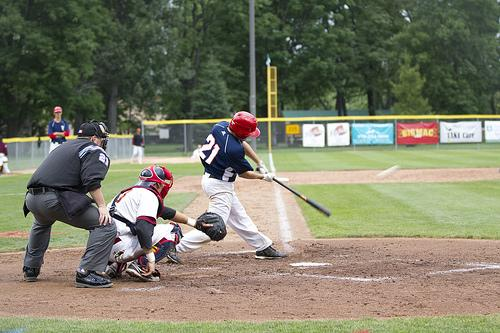Assess the image quality in terms of clarity and composition. The image quality is generally good, featuring clear details of the game, players, and surrounding elements, though it could be better composed by focusing on a few key aspects. Briefly describe any object interactions observed within the baseball field. The batter has just hit the ball, an umpire is crouching behind the catcher, and the third base coach watches from the sidelines. What is the sentiment conveyed by the image? The image conveys excitement and competition as it captures various actions of a fast-paced baseball game. List the key objects and where they are located using their top-left corner coordinates (X, Y). Umpire: (18, 115), Blue-jersey batter: (193, 116), White-jersey catcher: (98, 181), Red batting helmet: (225, 105), Metal fence: (143, 121), White home plate: (290, 259). Count the total number of unique persons in the image. There are at least 6 unique persons, including the batter, catcher, umpire, third base coach, and two individuals in the background. What activity is predominantly taking place in the image? A baseball game is taking place with various players performing different actions. Mention the colors of the teams' jerseys in the image and what roles they correspond to. The batter's team wears blue jerseys, the catcher's team wears white jerseys, and the umpire traditionally wears black. In this baseball game, which team traditionally wears white? The home team. Describe the motion of the batter. The batter has just hit the ball. What is the role of the person crouching behind the catcher? Umpire. Create a detailed image caption that captures the scene. A tense moment on a baseball field where the batter in a blue jersey hits the ball, surrounded by an umpire in black, and teammates in white; sponsors' banners line the fence. Describe the position of the man standing in the baseball field. On the sidelines. Can you see a pink elephant on the baseball field? There is no mention or indication of a pink elephant in the image, and it is not relevant to the context of a baseball game. Are there fireworks going off in the background of the image? There is no mention or indication of fireworks in the image, and it is not relevant to the context of a baseball game. What is the color of the catcher's mitt? Black. Is the umpire wearing a bright green outfit? The umpire is traditionally wearing black, not bright green. What is happening on the baseball field? People are playing a game, with a batter hitting the ball, a catcher behind him, and an umpire observing. How is the third base coach positioned? He's watching from the sidelines. Is the batter's helmet red or blue? Answer:  Which object helps decide if a baseball stays in the field of play? Yellow pole in the baseball field. What color is the home team's jerseys? White. Is there a giant spaceship hovering above the baseball field? There is no mention or indication of a spaceship in the image, and it is not relevant to the context of a baseball game. Contrast the jersey colors of the batters and catchers teams. The batters team wears blue jerseys, while the catchers team is wearing white jerseys. Answer the question that best describes the yellow pole. It helps determine if a ball stays fair. Which object serves as the boundary of the baseball field? A metal fence. What does the text on the boy's jersey signify? The number 21. What color is the umpire's attire? Black Does the batter have a purple helmet? The helmet is red and not purple, as mentioned multiple times in the captions. What is the purpose of the banners on the fence? Advertisement. Is the catcher's team wearing bright yellow jerseys? The catcher's team is wearing white jerseys, not bright yellow as described in the instruction. 